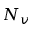<formula> <loc_0><loc_0><loc_500><loc_500>N _ { v }</formula> 